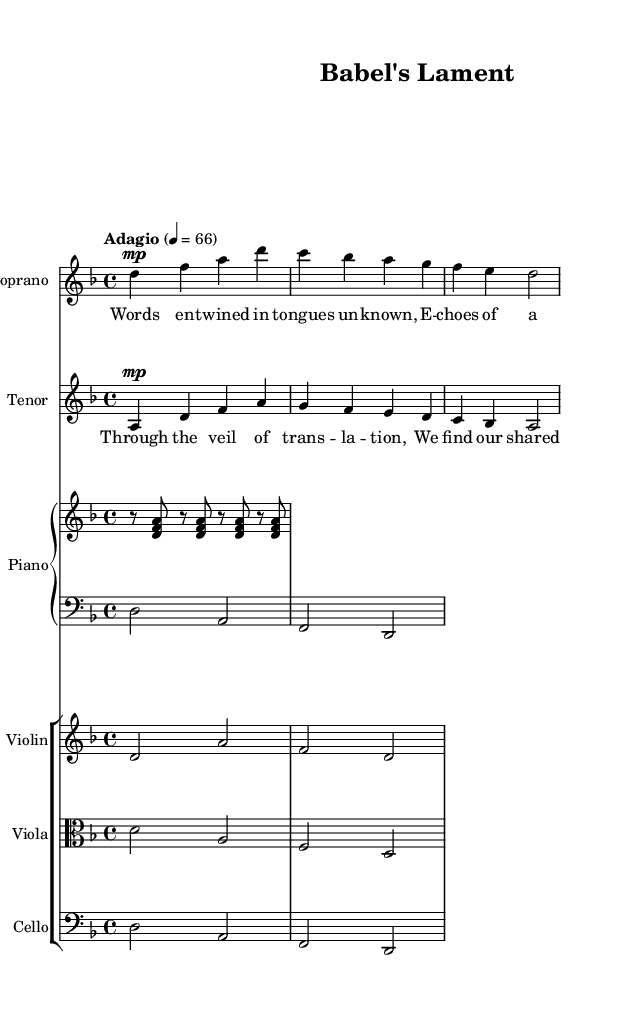What is the key signature of this music? The key signature is indicated at the beginning of the piece, showing two flat symbols, which correspond to the notes B and E. This indicates that the music is in D minor, which has one flat in its relative major, F major.
Answer: D minor What is the time signature of this music? The time signature is shown at the beginning of the score as 4 over 4, meaning there are four beats in each measure and the quarter note receives one beat.
Answer: 4/4 What is the tempo marking of this music? The tempo marking is written as "Adagio" followed by a metronome marking of 66, which suggests that the piece should be played slowly.
Answer: Adagio Which voice performs the higher melody? By comparing the soprano and tenor parts, the soprano voice is written in the higher range, indicating it sings the higher melody, while the tenor is lower.
Answer: Soprano How many instruments are present in the score? The score consists of five distinct parts: soprano, tenor, piano (which is split into right and left hands), violin, viola, and cello. Counting these gives a total of six instruments.
Answer: Six What thematic concept do the lyrics of the soprano and tenor suggest about language? The soprano lyrics refer to "twined in tongues unknown," suggesting a rich tapestry of diverse languages, while the tenor speaks of "the veil of translation," indicating a connection through shared meanings. This shows the exploration of language barriers and communication.
Answer: Power of language What type of music is represented in this score? The term "opera" is explicitly stated in the context of this music, which implies the piece is a vocal drama combining musical and theatrical elements, typically involving various languages and storytelling techniques inherent to operatic works.
Answer: Opera 